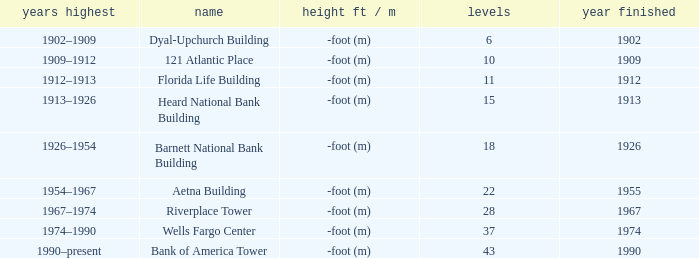What year was the building completed that has 10 floors? 1909.0. 